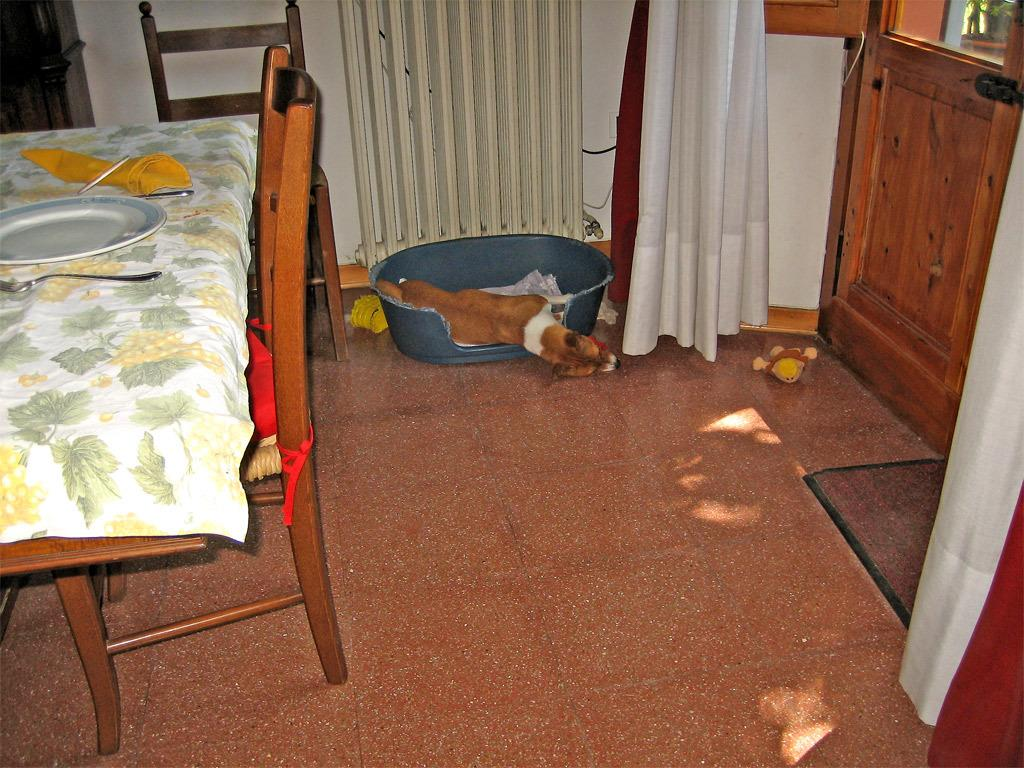What color is the wall in the image? The wall in the image is white. What type of window treatment is present in the image? There is a curtain in the image. What piece of furniture is in the image? There is a dining table in the image. What animal can be seen in the image? There is a dog in the image. What is placed on the dining table? There is a plate on the dining table. What utensils are on the dining table? There are spoons on the dining table. Where is the amusement park located in the image? There is no amusement park present in the image. What type of spider web can be seen on the curtain in the image? There is no spider web, or cobweb, present on the curtain in the image. 